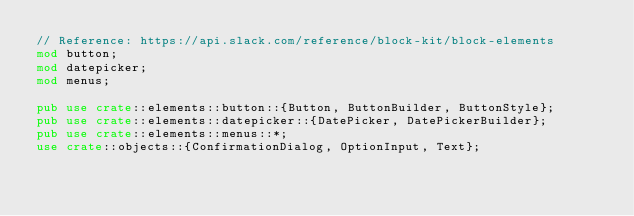<code> <loc_0><loc_0><loc_500><loc_500><_Rust_>// Reference: https://api.slack.com/reference/block-kit/block-elements
mod button;
mod datepicker;
mod menus;

pub use crate::elements::button::{Button, ButtonBuilder, ButtonStyle};
pub use crate::elements::datepicker::{DatePicker, DatePickerBuilder};
pub use crate::elements::menus::*;
use crate::objects::{ConfirmationDialog, OptionInput, Text};
</code> 